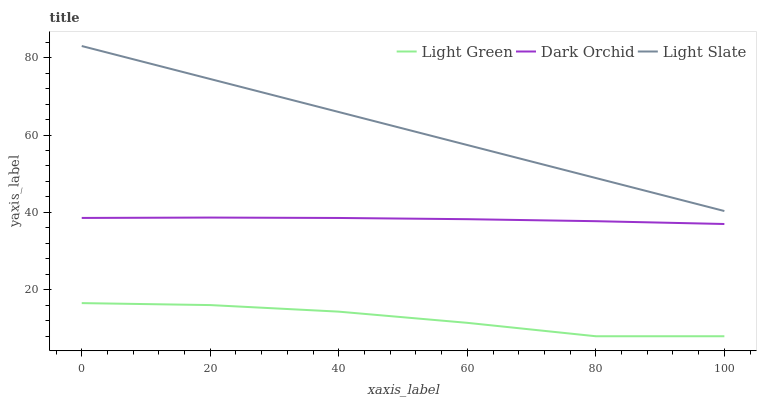Does Light Green have the minimum area under the curve?
Answer yes or no. Yes. Does Light Slate have the maximum area under the curve?
Answer yes or no. Yes. Does Dark Orchid have the minimum area under the curve?
Answer yes or no. No. Does Dark Orchid have the maximum area under the curve?
Answer yes or no. No. Is Light Slate the smoothest?
Answer yes or no. Yes. Is Light Green the roughest?
Answer yes or no. Yes. Is Dark Orchid the smoothest?
Answer yes or no. No. Is Dark Orchid the roughest?
Answer yes or no. No. Does Light Green have the lowest value?
Answer yes or no. Yes. Does Dark Orchid have the lowest value?
Answer yes or no. No. Does Light Slate have the highest value?
Answer yes or no. Yes. Does Dark Orchid have the highest value?
Answer yes or no. No. Is Light Green less than Light Slate?
Answer yes or no. Yes. Is Dark Orchid greater than Light Green?
Answer yes or no. Yes. Does Light Green intersect Light Slate?
Answer yes or no. No. 